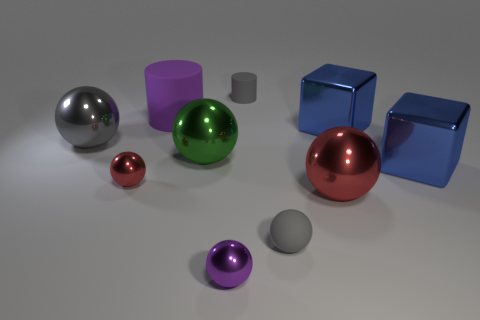How many other things are there of the same color as the small rubber cylinder?
Keep it short and to the point. 2. Do the tiny purple sphere and the red thing to the right of the purple shiny object have the same material?
Make the answer very short. Yes. How many small matte things are in front of the small matte thing behind the red metal thing that is to the right of the small red sphere?
Provide a succinct answer. 1. Are there fewer big cubes that are to the left of the big purple rubber object than small purple metallic things that are in front of the small red shiny sphere?
Your answer should be very brief. Yes. What number of other objects are there of the same material as the green object?
Offer a very short reply. 6. There is a red object that is the same size as the gray cylinder; what is it made of?
Give a very brief answer. Metal. How many brown things are either spheres or small spheres?
Your response must be concise. 0. There is a tiny object that is both behind the small gray ball and on the left side of the gray cylinder; what color is it?
Provide a succinct answer. Red. Is the blue cube in front of the large gray thing made of the same material as the gray thing that is in front of the small red thing?
Your answer should be very brief. No. Are there more large objects to the right of the purple sphere than big green objects that are on the left side of the big gray thing?
Keep it short and to the point. Yes. 